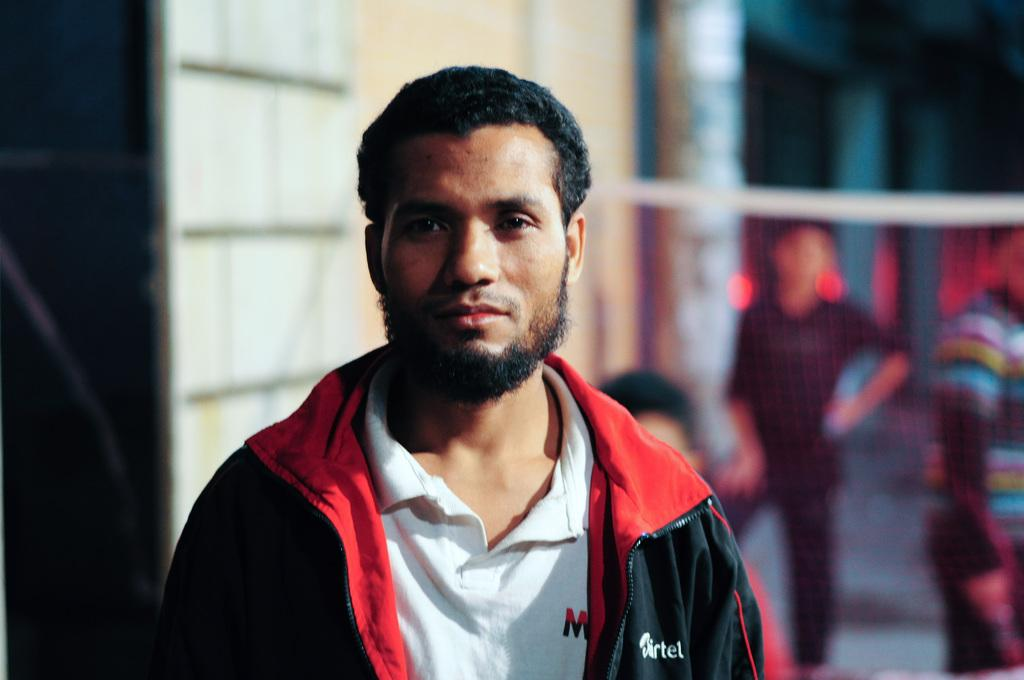Who is the main subject in the image? There is a man in the center of the image. What can be seen in the background of the image? There are people and a wall in the background of the image. What is visible at the bottom of the image? The floor is visible at the bottom of the image. How many trees are visible in the image? There are no trees visible in the image. What type of hat is the man wearing in the image? The man is not wearing a hat in the image. 